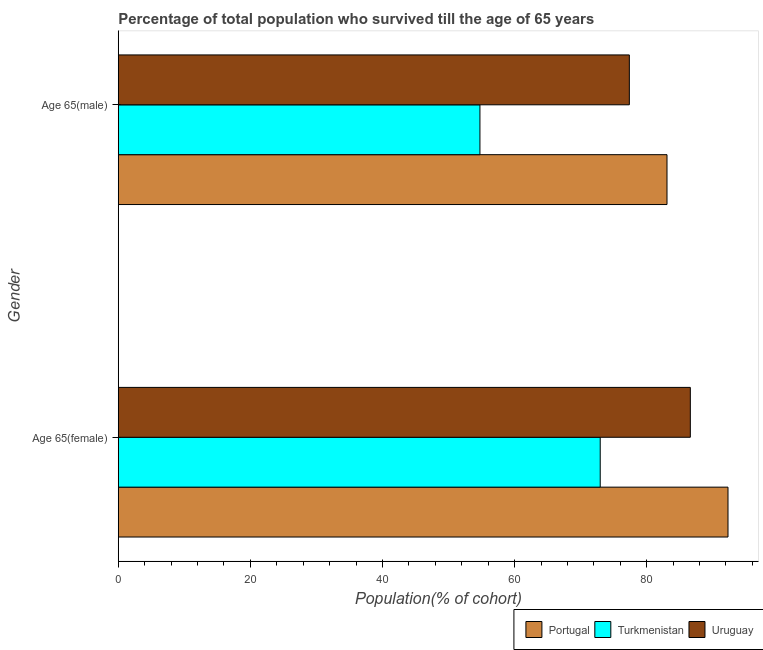Are the number of bars per tick equal to the number of legend labels?
Make the answer very short. Yes. Are the number of bars on each tick of the Y-axis equal?
Ensure brevity in your answer.  Yes. How many bars are there on the 1st tick from the bottom?
Give a very brief answer. 3. What is the label of the 1st group of bars from the top?
Make the answer very short. Age 65(male). What is the percentage of male population who survived till age of 65 in Turkmenistan?
Your answer should be very brief. 54.75. Across all countries, what is the maximum percentage of female population who survived till age of 65?
Provide a short and direct response. 92.31. Across all countries, what is the minimum percentage of male population who survived till age of 65?
Give a very brief answer. 54.75. In which country was the percentage of male population who survived till age of 65 minimum?
Keep it short and to the point. Turkmenistan. What is the total percentage of male population who survived till age of 65 in the graph?
Give a very brief answer. 215.21. What is the difference between the percentage of female population who survived till age of 65 in Portugal and that in Uruguay?
Make the answer very short. 5.7. What is the difference between the percentage of female population who survived till age of 65 in Portugal and the percentage of male population who survived till age of 65 in Uruguay?
Give a very brief answer. 14.94. What is the average percentage of male population who survived till age of 65 per country?
Provide a short and direct response. 71.74. What is the difference between the percentage of female population who survived till age of 65 and percentage of male population who survived till age of 65 in Turkmenistan?
Provide a succinct answer. 18.21. In how many countries, is the percentage of female population who survived till age of 65 greater than 36 %?
Your answer should be compact. 3. What is the ratio of the percentage of female population who survived till age of 65 in Portugal to that in Turkmenistan?
Give a very brief answer. 1.27. In how many countries, is the percentage of female population who survived till age of 65 greater than the average percentage of female population who survived till age of 65 taken over all countries?
Provide a succinct answer. 2. What does the 2nd bar from the top in Age 65(female) represents?
Your answer should be compact. Turkmenistan. What does the 2nd bar from the bottom in Age 65(male) represents?
Offer a terse response. Turkmenistan. How many bars are there?
Make the answer very short. 6. How many countries are there in the graph?
Offer a terse response. 3. What is the difference between two consecutive major ticks on the X-axis?
Your answer should be very brief. 20. Where does the legend appear in the graph?
Offer a very short reply. Bottom right. How many legend labels are there?
Provide a succinct answer. 3. How are the legend labels stacked?
Your response must be concise. Horizontal. What is the title of the graph?
Your answer should be compact. Percentage of total population who survived till the age of 65 years. What is the label or title of the X-axis?
Offer a very short reply. Population(% of cohort). What is the Population(% of cohort) of Portugal in Age 65(female)?
Offer a very short reply. 92.31. What is the Population(% of cohort) in Turkmenistan in Age 65(female)?
Your response must be concise. 72.97. What is the Population(% of cohort) in Uruguay in Age 65(female)?
Keep it short and to the point. 86.61. What is the Population(% of cohort) in Portugal in Age 65(male)?
Your answer should be very brief. 83.08. What is the Population(% of cohort) of Turkmenistan in Age 65(male)?
Give a very brief answer. 54.75. What is the Population(% of cohort) in Uruguay in Age 65(male)?
Make the answer very short. 77.38. Across all Gender, what is the maximum Population(% of cohort) in Portugal?
Ensure brevity in your answer.  92.31. Across all Gender, what is the maximum Population(% of cohort) in Turkmenistan?
Offer a terse response. 72.97. Across all Gender, what is the maximum Population(% of cohort) of Uruguay?
Give a very brief answer. 86.61. Across all Gender, what is the minimum Population(% of cohort) in Portugal?
Your answer should be very brief. 83.08. Across all Gender, what is the minimum Population(% of cohort) of Turkmenistan?
Your response must be concise. 54.75. Across all Gender, what is the minimum Population(% of cohort) of Uruguay?
Provide a succinct answer. 77.38. What is the total Population(% of cohort) of Portugal in the graph?
Ensure brevity in your answer.  175.39. What is the total Population(% of cohort) in Turkmenistan in the graph?
Provide a short and direct response. 127.72. What is the total Population(% of cohort) of Uruguay in the graph?
Make the answer very short. 163.99. What is the difference between the Population(% of cohort) of Portugal in Age 65(female) and that in Age 65(male)?
Offer a very short reply. 9.24. What is the difference between the Population(% of cohort) of Turkmenistan in Age 65(female) and that in Age 65(male)?
Your response must be concise. 18.21. What is the difference between the Population(% of cohort) in Uruguay in Age 65(female) and that in Age 65(male)?
Provide a succinct answer. 9.23. What is the difference between the Population(% of cohort) in Portugal in Age 65(female) and the Population(% of cohort) in Turkmenistan in Age 65(male)?
Give a very brief answer. 37.56. What is the difference between the Population(% of cohort) of Portugal in Age 65(female) and the Population(% of cohort) of Uruguay in Age 65(male)?
Provide a succinct answer. 14.94. What is the difference between the Population(% of cohort) of Turkmenistan in Age 65(female) and the Population(% of cohort) of Uruguay in Age 65(male)?
Make the answer very short. -4.41. What is the average Population(% of cohort) of Portugal per Gender?
Your answer should be very brief. 87.7. What is the average Population(% of cohort) in Turkmenistan per Gender?
Ensure brevity in your answer.  63.86. What is the average Population(% of cohort) in Uruguay per Gender?
Provide a short and direct response. 81.99. What is the difference between the Population(% of cohort) in Portugal and Population(% of cohort) in Turkmenistan in Age 65(female)?
Give a very brief answer. 19.35. What is the difference between the Population(% of cohort) in Portugal and Population(% of cohort) in Uruguay in Age 65(female)?
Keep it short and to the point. 5.7. What is the difference between the Population(% of cohort) of Turkmenistan and Population(% of cohort) of Uruguay in Age 65(female)?
Give a very brief answer. -13.64. What is the difference between the Population(% of cohort) in Portugal and Population(% of cohort) in Turkmenistan in Age 65(male)?
Provide a succinct answer. 28.32. What is the difference between the Population(% of cohort) of Portugal and Population(% of cohort) of Uruguay in Age 65(male)?
Give a very brief answer. 5.7. What is the difference between the Population(% of cohort) of Turkmenistan and Population(% of cohort) of Uruguay in Age 65(male)?
Give a very brief answer. -22.62. What is the ratio of the Population(% of cohort) of Portugal in Age 65(female) to that in Age 65(male)?
Your response must be concise. 1.11. What is the ratio of the Population(% of cohort) of Turkmenistan in Age 65(female) to that in Age 65(male)?
Make the answer very short. 1.33. What is the ratio of the Population(% of cohort) in Uruguay in Age 65(female) to that in Age 65(male)?
Give a very brief answer. 1.12. What is the difference between the highest and the second highest Population(% of cohort) of Portugal?
Provide a succinct answer. 9.24. What is the difference between the highest and the second highest Population(% of cohort) of Turkmenistan?
Give a very brief answer. 18.21. What is the difference between the highest and the second highest Population(% of cohort) in Uruguay?
Ensure brevity in your answer.  9.23. What is the difference between the highest and the lowest Population(% of cohort) in Portugal?
Ensure brevity in your answer.  9.24. What is the difference between the highest and the lowest Population(% of cohort) in Turkmenistan?
Provide a succinct answer. 18.21. What is the difference between the highest and the lowest Population(% of cohort) of Uruguay?
Offer a very short reply. 9.23. 